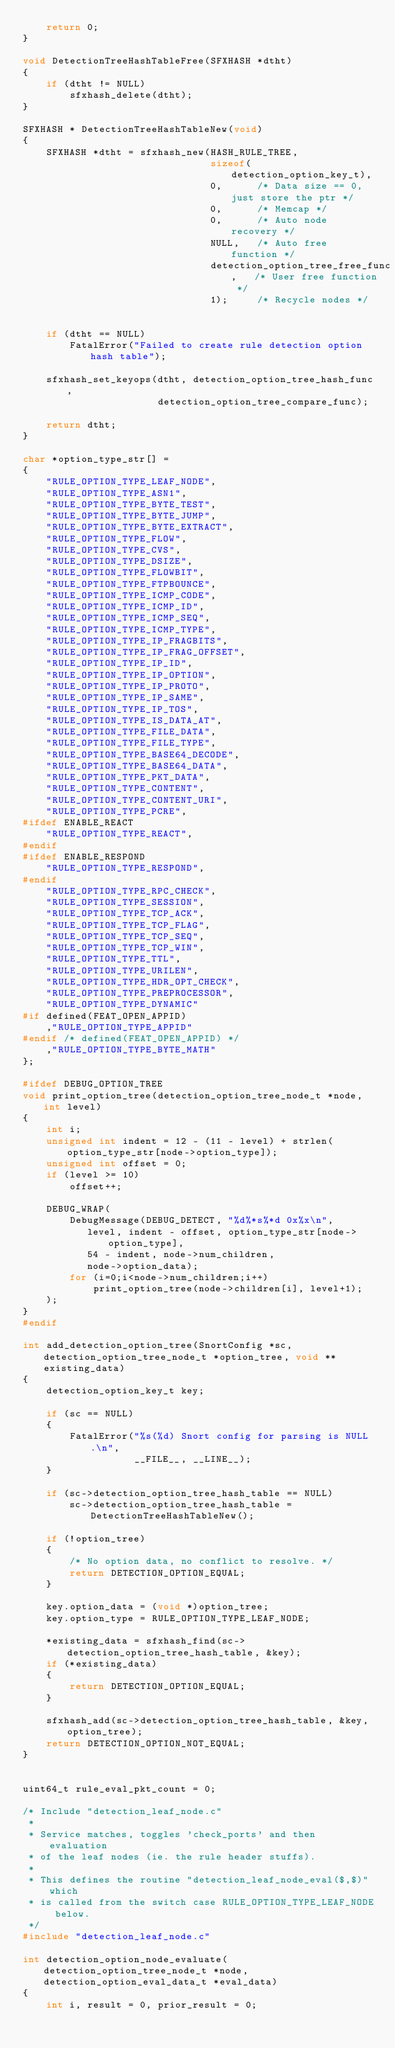<code> <loc_0><loc_0><loc_500><loc_500><_C_>    return 0;
}

void DetectionTreeHashTableFree(SFXHASH *dtht)
{
    if (dtht != NULL)
        sfxhash_delete(dtht);
}

SFXHASH * DetectionTreeHashTableNew(void)
{
    SFXHASH *dtht = sfxhash_new(HASH_RULE_TREE,
                                sizeof(detection_option_key_t),
                                0,      /* Data size == 0, just store the ptr */
                                0,      /* Memcap */
                                0,      /* Auto node recovery */
                                NULL,   /* Auto free function */
                                detection_option_tree_free_func,   /* User free function */
                                1);     /* Recycle nodes */


    if (dtht == NULL)
        FatalError("Failed to create rule detection option hash table");

    sfxhash_set_keyops(dtht, detection_option_tree_hash_func,
                       detection_option_tree_compare_func);

    return dtht;
}

char *option_type_str[] =
{
    "RULE_OPTION_TYPE_LEAF_NODE",
    "RULE_OPTION_TYPE_ASN1",
    "RULE_OPTION_TYPE_BYTE_TEST",
    "RULE_OPTION_TYPE_BYTE_JUMP",
    "RULE_OPTION_TYPE_BYTE_EXTRACT",
    "RULE_OPTION_TYPE_FLOW",
    "RULE_OPTION_TYPE_CVS",
    "RULE_OPTION_TYPE_DSIZE",
    "RULE_OPTION_TYPE_FLOWBIT",
    "RULE_OPTION_TYPE_FTPBOUNCE",
    "RULE_OPTION_TYPE_ICMP_CODE",
    "RULE_OPTION_TYPE_ICMP_ID",
    "RULE_OPTION_TYPE_ICMP_SEQ",
    "RULE_OPTION_TYPE_ICMP_TYPE",
    "RULE_OPTION_TYPE_IP_FRAGBITS",
    "RULE_OPTION_TYPE_IP_FRAG_OFFSET",
    "RULE_OPTION_TYPE_IP_ID",
    "RULE_OPTION_TYPE_IP_OPTION",
    "RULE_OPTION_TYPE_IP_PROTO",
    "RULE_OPTION_TYPE_IP_SAME",
    "RULE_OPTION_TYPE_IP_TOS",
    "RULE_OPTION_TYPE_IS_DATA_AT",
    "RULE_OPTION_TYPE_FILE_DATA",
    "RULE_OPTION_TYPE_FILE_TYPE",
    "RULE_OPTION_TYPE_BASE64_DECODE",
    "RULE_OPTION_TYPE_BASE64_DATA",
    "RULE_OPTION_TYPE_PKT_DATA",
    "RULE_OPTION_TYPE_CONTENT",
    "RULE_OPTION_TYPE_CONTENT_URI",
    "RULE_OPTION_TYPE_PCRE",
#ifdef ENABLE_REACT
    "RULE_OPTION_TYPE_REACT",
#endif
#ifdef ENABLE_RESPOND
    "RULE_OPTION_TYPE_RESPOND",
#endif
    "RULE_OPTION_TYPE_RPC_CHECK",
    "RULE_OPTION_TYPE_SESSION",
    "RULE_OPTION_TYPE_TCP_ACK",
    "RULE_OPTION_TYPE_TCP_FLAG",
    "RULE_OPTION_TYPE_TCP_SEQ",
    "RULE_OPTION_TYPE_TCP_WIN",
    "RULE_OPTION_TYPE_TTL",
    "RULE_OPTION_TYPE_URILEN",
    "RULE_OPTION_TYPE_HDR_OPT_CHECK",
    "RULE_OPTION_TYPE_PREPROCESSOR",
    "RULE_OPTION_TYPE_DYNAMIC"
#if defined(FEAT_OPEN_APPID)
    ,"RULE_OPTION_TYPE_APPID"
#endif /* defined(FEAT_OPEN_APPID) */
    ,"RULE_OPTION_TYPE_BYTE_MATH"
};

#ifdef DEBUG_OPTION_TREE
void print_option_tree(detection_option_tree_node_t *node, int level)
{
    int i;
    unsigned int indent = 12 - (11 - level) + strlen(option_type_str[node->option_type]);
    unsigned int offset = 0;
    if (level >= 10)
        offset++;

    DEBUG_WRAP(
        DebugMessage(DEBUG_DETECT, "%d%*s%*d 0x%x\n",
           level, indent - offset, option_type_str[node->option_type],
           54 - indent, node->num_children,
           node->option_data);
        for (i=0;i<node->num_children;i++)
            print_option_tree(node->children[i], level+1);
    );
}
#endif

int add_detection_option_tree(SnortConfig *sc, detection_option_tree_node_t *option_tree, void **existing_data)
{
    detection_option_key_t key;

    if (sc == NULL)
    {
        FatalError("%s(%d) Snort config for parsing is NULL.\n",
                   __FILE__, __LINE__);
    }

    if (sc->detection_option_tree_hash_table == NULL)
        sc->detection_option_tree_hash_table = DetectionTreeHashTableNew();

    if (!option_tree)
    {
        /* No option data, no conflict to resolve. */
        return DETECTION_OPTION_EQUAL;
    }

    key.option_data = (void *)option_tree;
    key.option_type = RULE_OPTION_TYPE_LEAF_NODE;

    *existing_data = sfxhash_find(sc->detection_option_tree_hash_table, &key);
    if (*existing_data)
    {
        return DETECTION_OPTION_EQUAL;
    }

    sfxhash_add(sc->detection_option_tree_hash_table, &key, option_tree);
    return DETECTION_OPTION_NOT_EQUAL;
}


uint64_t rule_eval_pkt_count = 0;

/* Include "detection_leaf_node.c"
 *
 * Service matches, toggles 'check_ports' and then evaluation
 * of the leaf nodes (ie. the rule header stuffs).
 *
 * This defines the routine "detection_leaf_node_eval($,$)" which
 * is called from the switch case RULE_OPTION_TYPE_LEAF_NODE below.
 */
#include "detection_leaf_node.c"

int detection_option_node_evaluate(detection_option_tree_node_t *node, detection_option_eval_data_t *eval_data)
{
    int i, result = 0, prior_result = 0;</code> 